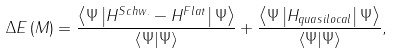<formula> <loc_0><loc_0><loc_500><loc_500>\Delta E \left ( M \right ) = \frac { \left \langle \Psi \left | H ^ { S c h w . } - H ^ { F l a t } \right | \Psi \right \rangle } { \left \langle \Psi | \Psi \right \rangle } + \frac { \left \langle \Psi \left | H _ { q u a s i l o c a l } \right | \Psi \right \rangle } { \left \langle \Psi | \Psi \right \rangle } ,</formula> 